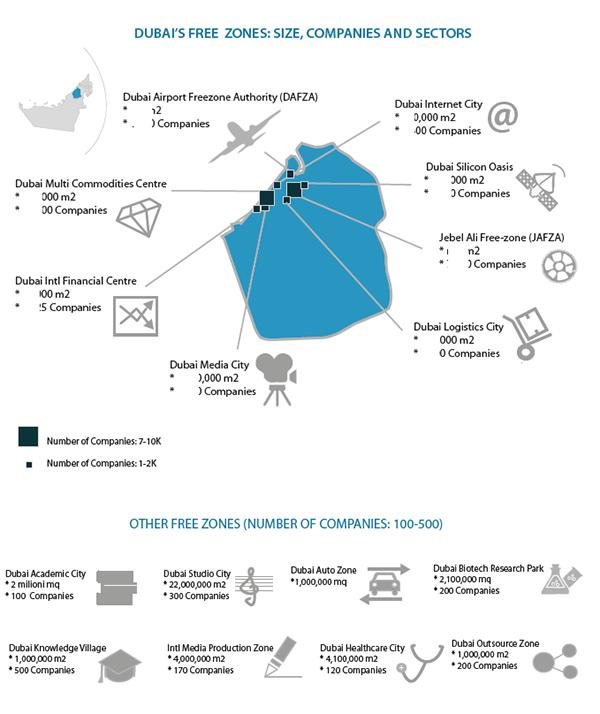Mention a couple of crucial points in this snapshot. Dubai Multi Commodities Centre is a company that is listed on the left side of the map and has approximately 7,000 to 10,000 companies within it. 